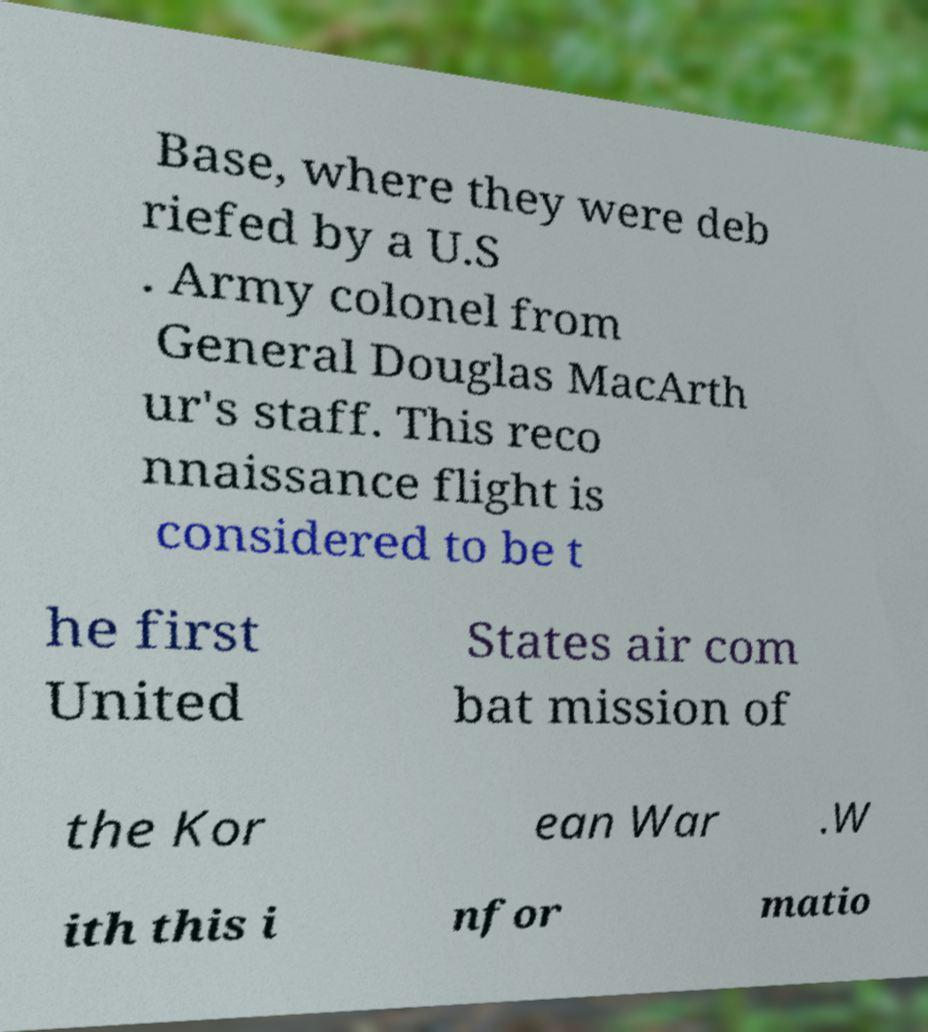Can you accurately transcribe the text from the provided image for me? Base, where they were deb riefed by a U.S . Army colonel from General Douglas MacArth ur's staff. This reco nnaissance flight is considered to be t he first United States air com bat mission of the Kor ean War .W ith this i nfor matio 